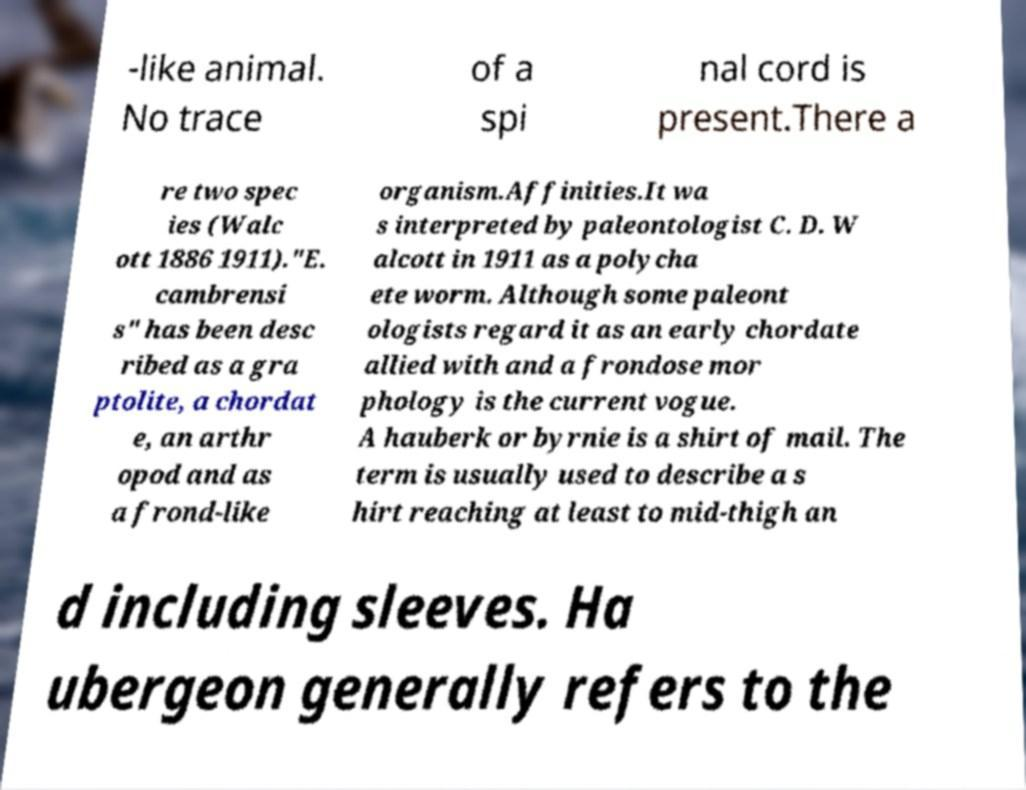I need the written content from this picture converted into text. Can you do that? -like animal. No trace of a spi nal cord is present.There a re two spec ies (Walc ott 1886 1911)."E. cambrensi s" has been desc ribed as a gra ptolite, a chordat e, an arthr opod and as a frond-like organism.Affinities.It wa s interpreted by paleontologist C. D. W alcott in 1911 as a polycha ete worm. Although some paleont ologists regard it as an early chordate allied with and a frondose mor phology is the current vogue. A hauberk or byrnie is a shirt of mail. The term is usually used to describe a s hirt reaching at least to mid-thigh an d including sleeves. Ha ubergeon generally refers to the 